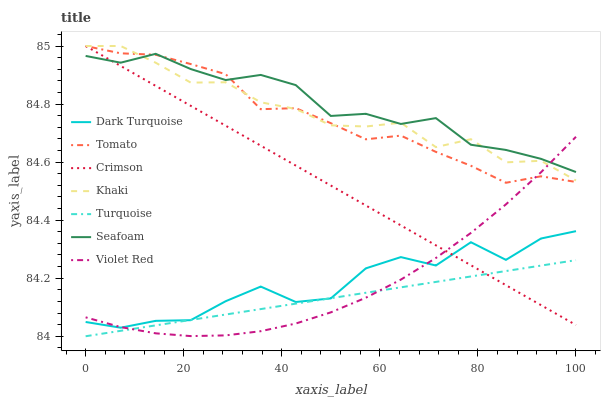Does Turquoise have the minimum area under the curve?
Answer yes or no. Yes. Does Seafoam have the maximum area under the curve?
Answer yes or no. Yes. Does Violet Red have the minimum area under the curve?
Answer yes or no. No. Does Violet Red have the maximum area under the curve?
Answer yes or no. No. Is Turquoise the smoothest?
Answer yes or no. Yes. Is Dark Turquoise the roughest?
Answer yes or no. Yes. Is Violet Red the smoothest?
Answer yes or no. No. Is Violet Red the roughest?
Answer yes or no. No. Does Turquoise have the lowest value?
Answer yes or no. Yes. Does Violet Red have the lowest value?
Answer yes or no. No. Does Crimson have the highest value?
Answer yes or no. Yes. Does Violet Red have the highest value?
Answer yes or no. No. Is Dark Turquoise less than Tomato?
Answer yes or no. Yes. Is Khaki greater than Turquoise?
Answer yes or no. Yes. Does Violet Red intersect Dark Turquoise?
Answer yes or no. Yes. Is Violet Red less than Dark Turquoise?
Answer yes or no. No. Is Violet Red greater than Dark Turquoise?
Answer yes or no. No. Does Dark Turquoise intersect Tomato?
Answer yes or no. No. 